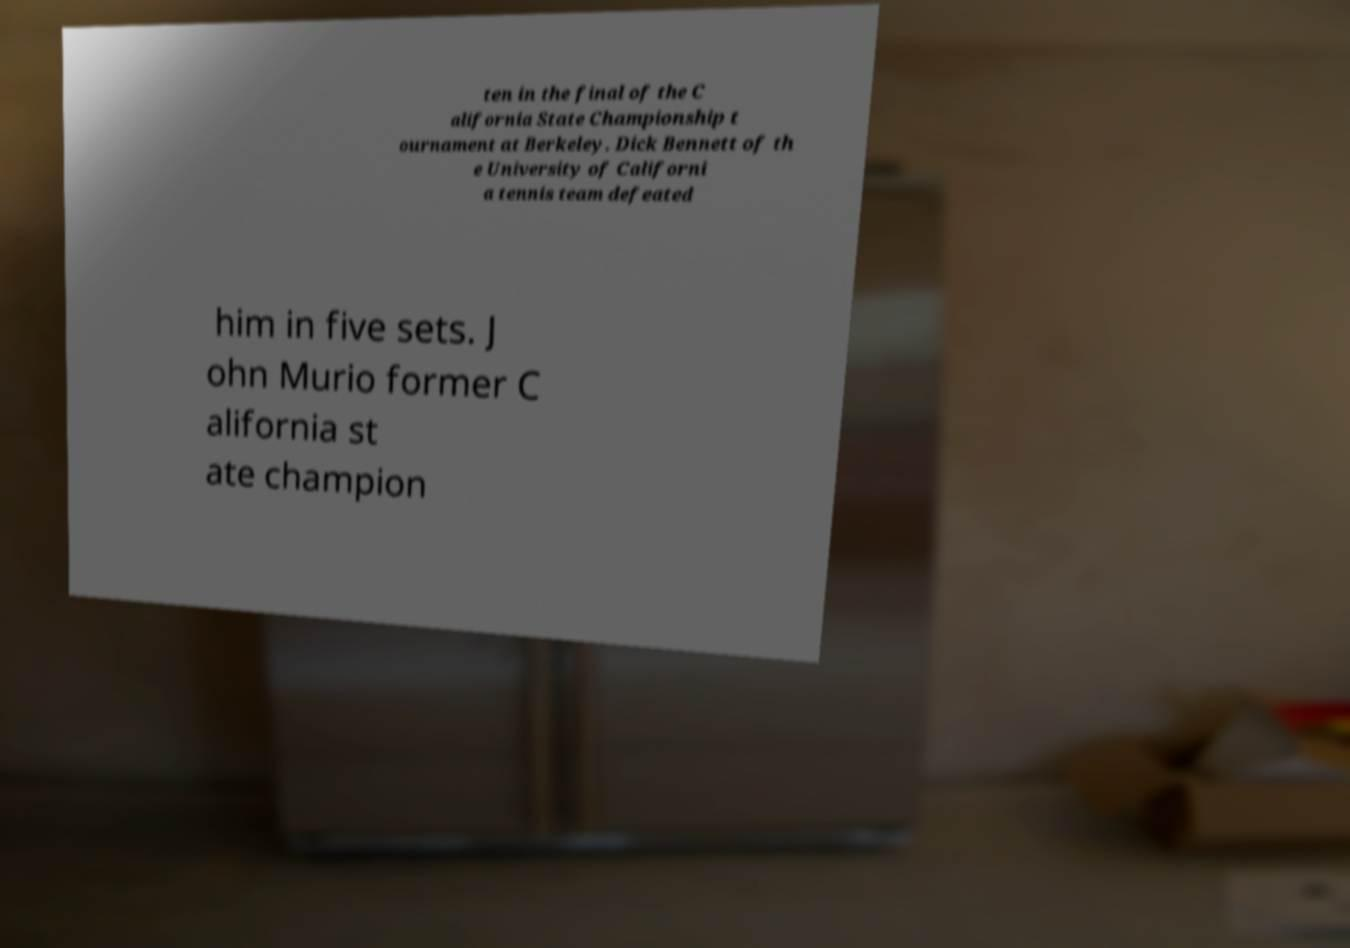Could you extract and type out the text from this image? ten in the final of the C alifornia State Championship t ournament at Berkeley. Dick Bennett of th e University of Californi a tennis team defeated him in five sets. J ohn Murio former C alifornia st ate champion 